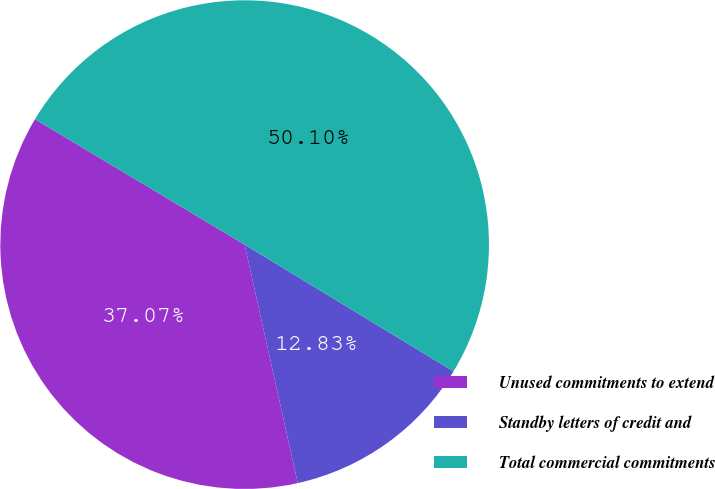Convert chart to OTSL. <chart><loc_0><loc_0><loc_500><loc_500><pie_chart><fcel>Unused commitments to extend<fcel>Standby letters of credit and<fcel>Total commercial commitments<nl><fcel>37.07%<fcel>12.83%<fcel>50.1%<nl></chart> 